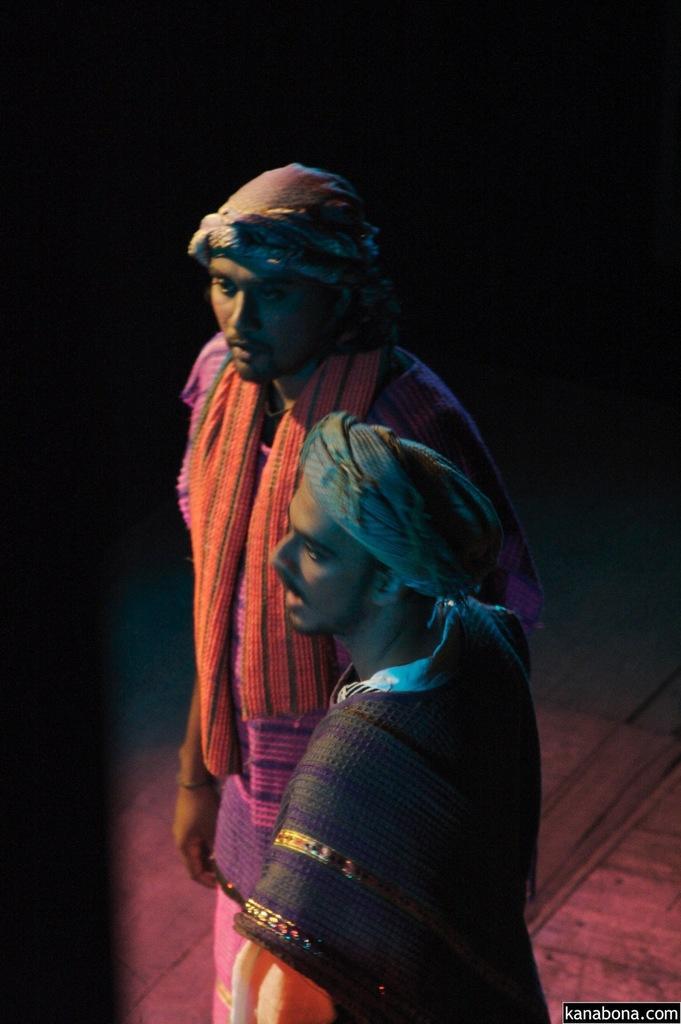Could you give a brief overview of what you see in this image? As we can see in the image there are two people standing in the front and the background is dark. 